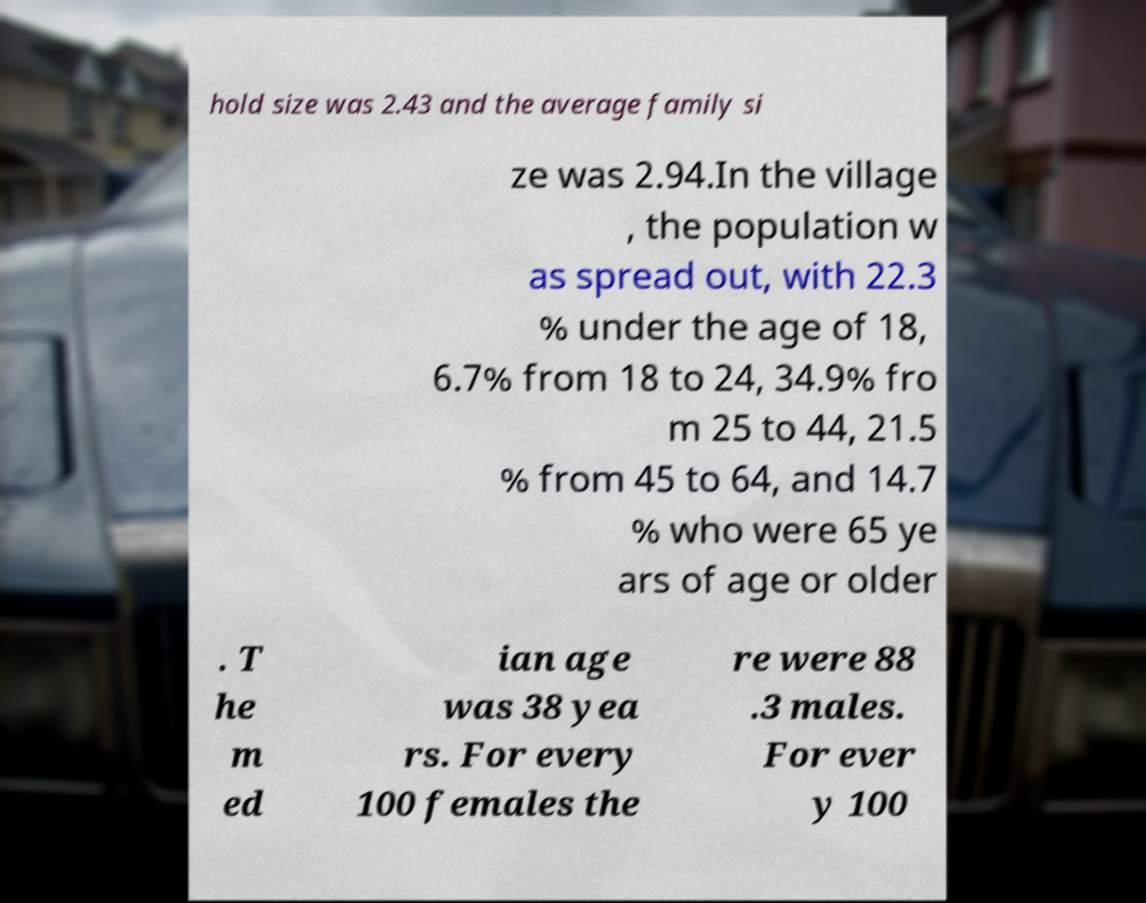Can you accurately transcribe the text from the provided image for me? hold size was 2.43 and the average family si ze was 2.94.In the village , the population w as spread out, with 22.3 % under the age of 18, 6.7% from 18 to 24, 34.9% fro m 25 to 44, 21.5 % from 45 to 64, and 14.7 % who were 65 ye ars of age or older . T he m ed ian age was 38 yea rs. For every 100 females the re were 88 .3 males. For ever y 100 